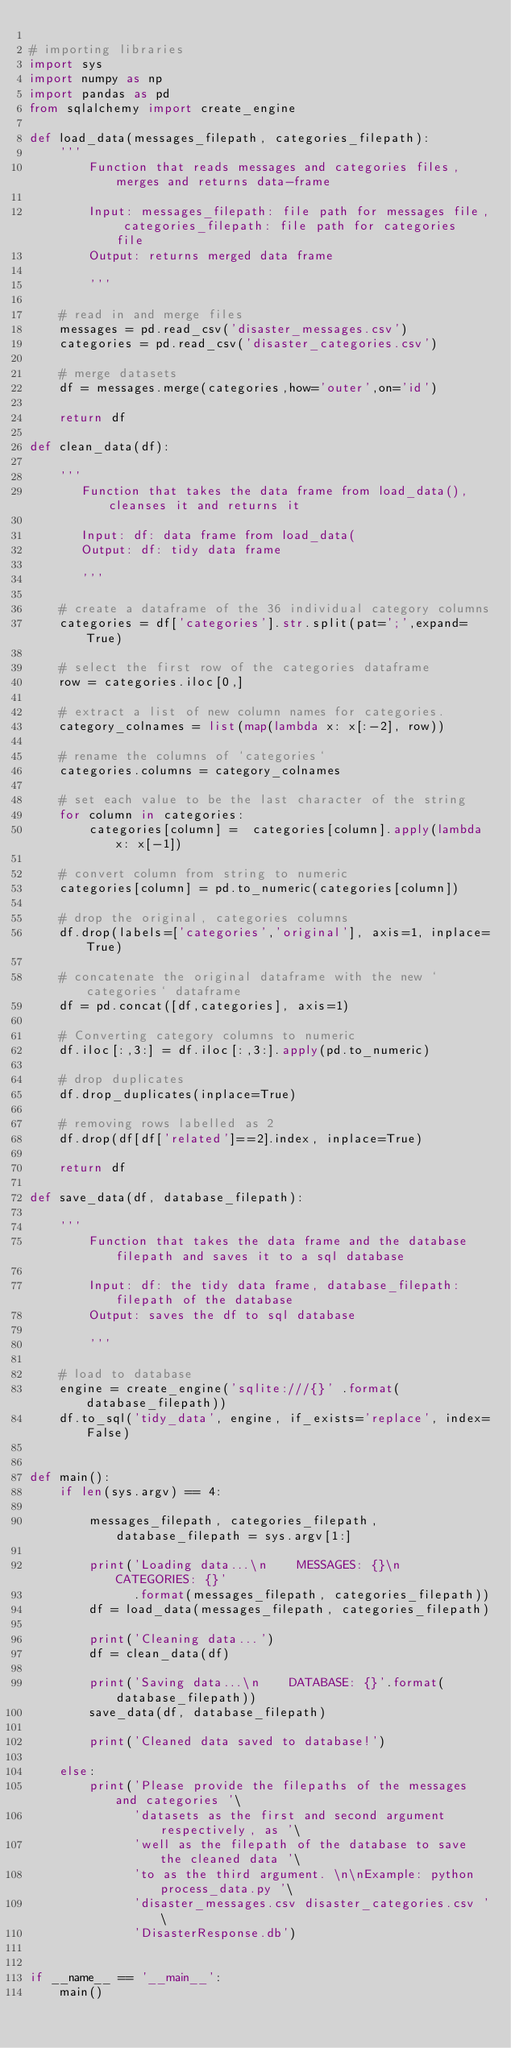Convert code to text. <code><loc_0><loc_0><loc_500><loc_500><_Python_>
# importing libraries
import sys
import numpy as np
import pandas as pd
from sqlalchemy import create_engine

def load_data(messages_filepath, categories_filepath):
    '''
        Function that reads messages and categories files, merges and returns data-frame

        Input: messages_filepath: file path for messages file, categories_filepath: file path for categories file
        Output: returns merged data frame

        '''

    # read in and merge files 
    messages = pd.read_csv('disaster_messages.csv')             
    categories = pd.read_csv('disaster_categories.csv')         
    
    # merge datasets
    df = messages.merge(categories,how='outer',on='id')
    
    return df 

def clean_data(df):

    '''
       Function that takes the data frame from load_data(), cleanses it and returns it

       Input: df: data frame from load_data(
       Output: df: tidy data frame

       '''

    # create a dataframe of the 36 individual category columns
    categories = df['categories'].str.split(pat=';',expand=True)
    
    # select the first row of the categories dataframe
    row = categories.iloc[0,]

    # extract a list of new column names for categories.
    category_colnames = list(map(lambda x: x[:-2], row))

    # rename the columns of `categories`
    categories.columns = category_colnames

    # set each value to be the last character of the string
    for column in categories:
        categories[column] =  categories[column].apply(lambda x: x[-1])
    
    # convert column from string to numeric
    categories[column] = pd.to_numeric(categories[column]) 

    # drop the original, categories columns
    df.drop(labels=['categories','original'], axis=1, inplace=True)
    
    # concatenate the original dataframe with the new `categories` dataframe
    df = pd.concat([df,categories], axis=1)

    # Converting category columns to numeric
    df.iloc[:,3:] = df.iloc[:,3:].apply(pd.to_numeric)

    # drop duplicates
    df.drop_duplicates(inplace=True)
    
    # removing rows labelled as 2
    df.drop(df[df['related']==2].index, inplace=True)

    return df

def save_data(df, database_filepath):

    '''
        Function that takes the data frame and the database filepath and saves it to a sql database

        Input: df: the tidy data frame, database_filepath: filepath of the database
        Output: saves the df to sql database

        '''

    # load to database
    engine = create_engine('sqlite:///{}' .format(database_filepath))
    df.to_sql('tidy_data', engine, if_exists='replace', index=False) 


def main():
    if len(sys.argv) == 4:

        messages_filepath, categories_filepath, database_filepath = sys.argv[1:]

        print('Loading data...\n    MESSAGES: {}\n    CATEGORIES: {}'
              .format(messages_filepath, categories_filepath))
        df = load_data(messages_filepath, categories_filepath)

        print('Cleaning data...')
        df = clean_data(df)
        
        print('Saving data...\n    DATABASE: {}'.format(database_filepath))
        save_data(df, database_filepath)
        
        print('Cleaned data saved to database!')
    
    else:
        print('Please provide the filepaths of the messages and categories '\
              'datasets as the first and second argument respectively, as '\
              'well as the filepath of the database to save the cleaned data '\
              'to as the third argument. \n\nExample: python process_data.py '\
              'disaster_messages.csv disaster_categories.csv '\
              'DisasterResponse.db')


if __name__ == '__main__':
    main()</code> 